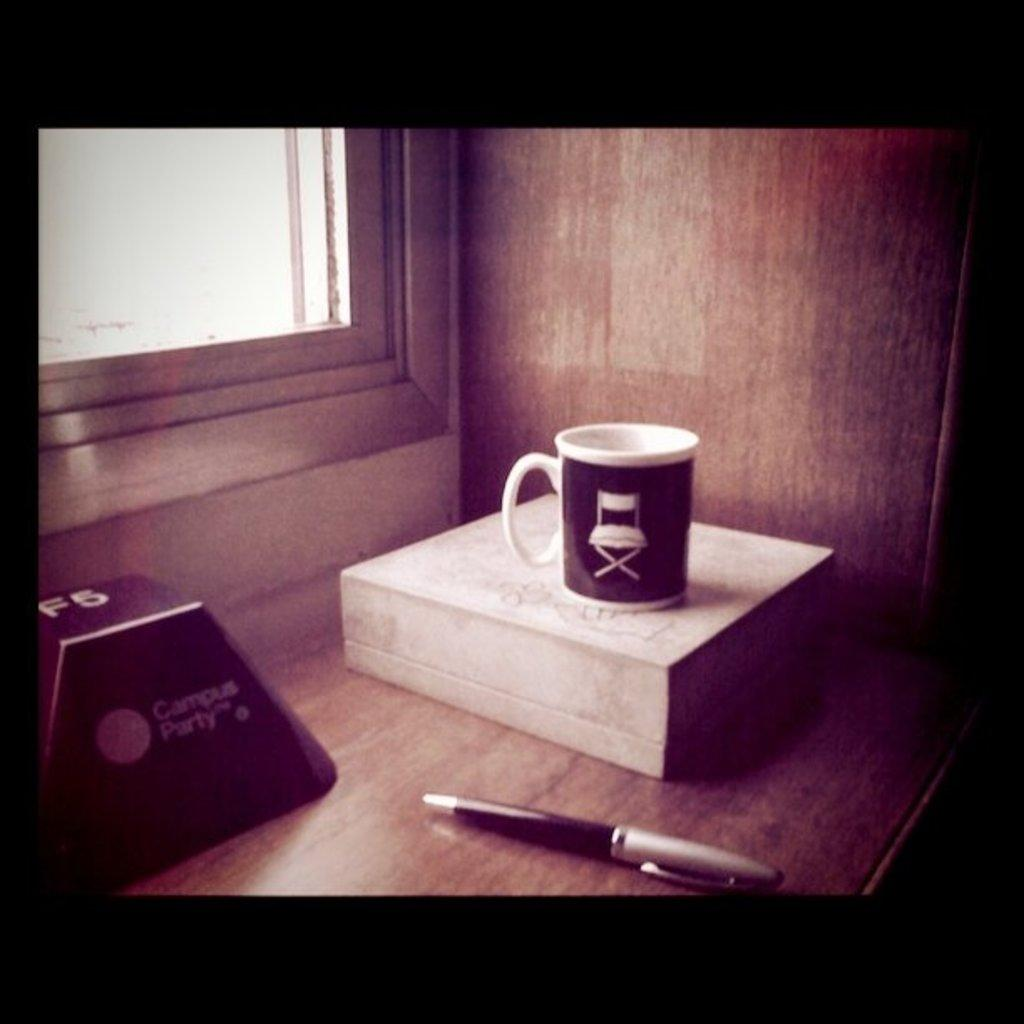What can be seen in the image that is used for holding liquids? There is a cup in the image that is used for holding liquids. What is the cup placed on in the image? The cup is on an object in the image. Where is the object with the cup located? The object with the cup is on a table in the image. What else can be seen on the table in the image? There is a pen and another object on the table in the image. What can be seen in the background of the image? There is a wall with a window in the background of the image. How many horses can be seen running through the window in the image? There are no horses visible in the image. 